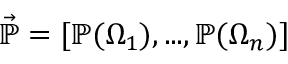Convert formula to latex. <formula><loc_0><loc_0><loc_500><loc_500>\vec { \mathbb { P } } = [ \mathbb { P } ( \Omega _ { 1 } ) , \dots , \mathbb { P } ( \Omega _ { n } ) ]</formula> 